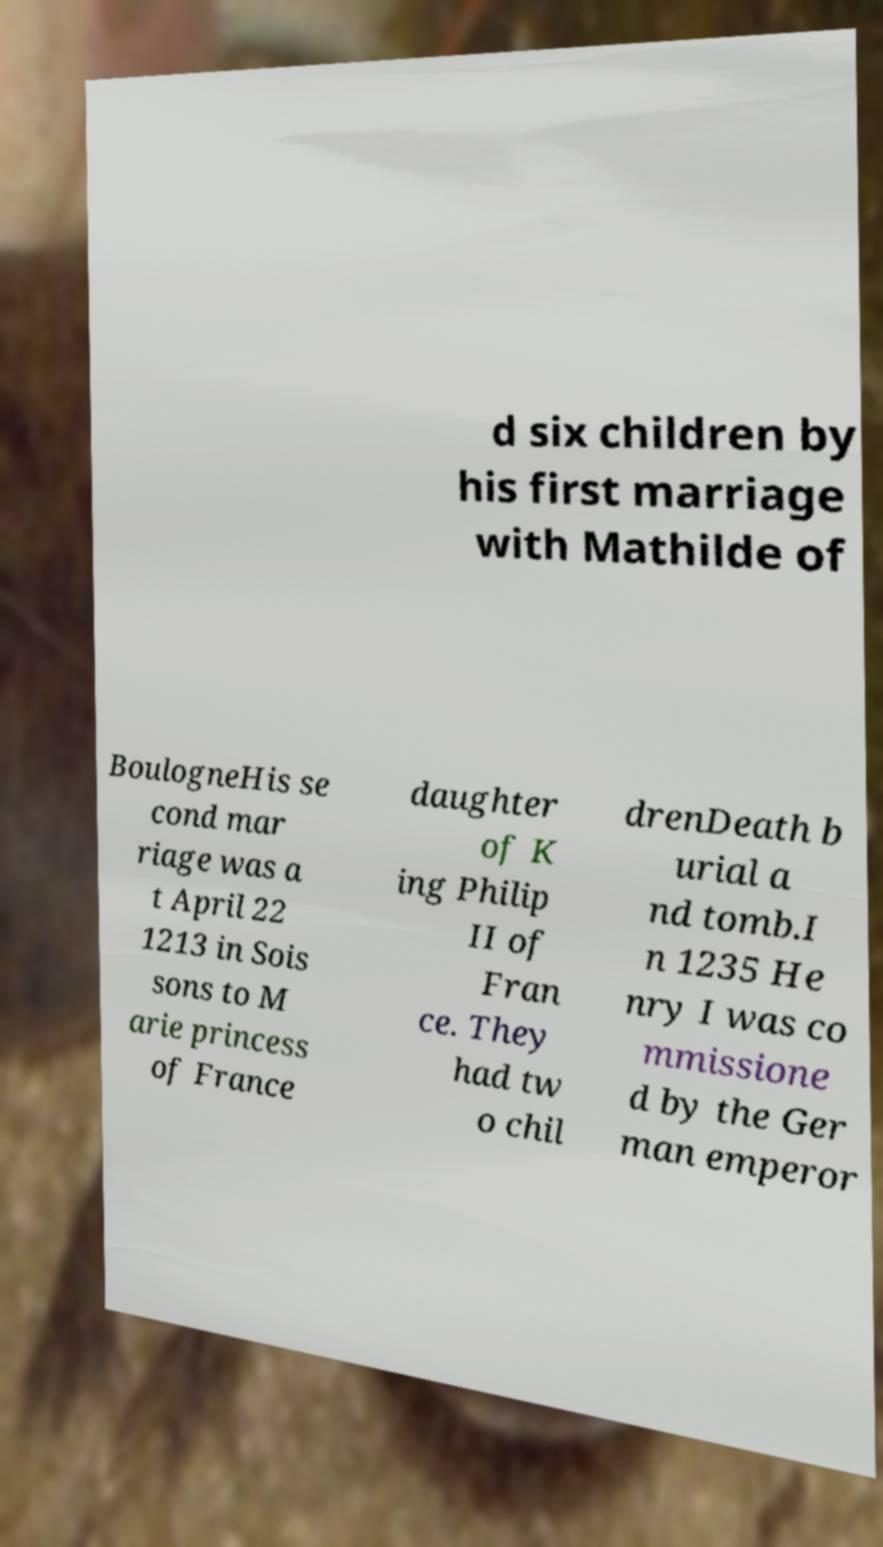Can you accurately transcribe the text from the provided image for me? d six children by his first marriage with Mathilde of BoulogneHis se cond mar riage was a t April 22 1213 in Sois sons to M arie princess of France daughter of K ing Philip II of Fran ce. They had tw o chil drenDeath b urial a nd tomb.I n 1235 He nry I was co mmissione d by the Ger man emperor 